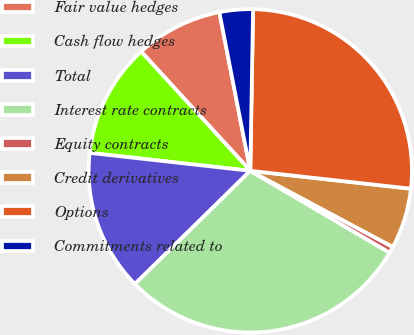<chart> <loc_0><loc_0><loc_500><loc_500><pie_chart><fcel>Fair value hedges<fcel>Cash flow hedges<fcel>Total<fcel>Interest rate contracts<fcel>Equity contracts<fcel>Credit derivatives<fcel>Options<fcel>Commitments related to<nl><fcel>8.73%<fcel>11.43%<fcel>14.12%<fcel>29.19%<fcel>0.65%<fcel>6.04%<fcel>26.49%<fcel>3.34%<nl></chart> 